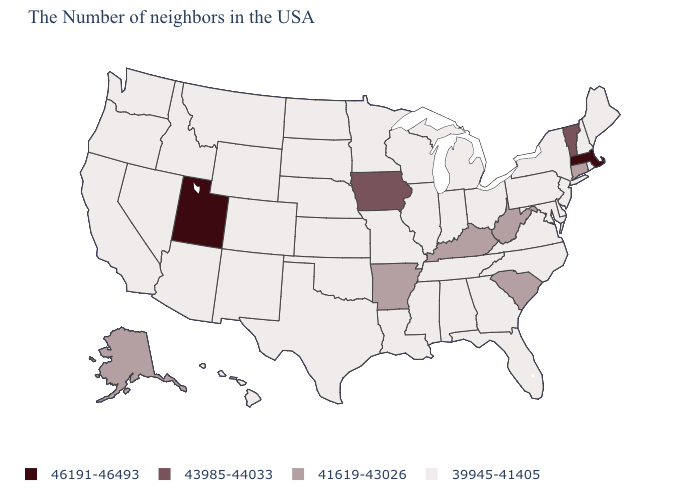Which states have the lowest value in the MidWest?
Answer briefly. Ohio, Michigan, Indiana, Wisconsin, Illinois, Missouri, Minnesota, Kansas, Nebraska, South Dakota, North Dakota. Which states have the lowest value in the South?
Quick response, please. Delaware, Maryland, Virginia, North Carolina, Florida, Georgia, Alabama, Tennessee, Mississippi, Louisiana, Oklahoma, Texas. What is the value of Rhode Island?
Give a very brief answer. 39945-41405. How many symbols are there in the legend?
Answer briefly. 4. Name the states that have a value in the range 46191-46493?
Give a very brief answer. Massachusetts, Utah. Does Minnesota have a lower value than Connecticut?
Short answer required. Yes. Name the states that have a value in the range 41619-43026?
Short answer required. Connecticut, South Carolina, West Virginia, Kentucky, Arkansas, Alaska. Name the states that have a value in the range 41619-43026?
Write a very short answer. Connecticut, South Carolina, West Virginia, Kentucky, Arkansas, Alaska. Which states have the highest value in the USA?
Keep it brief. Massachusetts, Utah. Does the map have missing data?
Keep it brief. No. What is the value of Louisiana?
Write a very short answer. 39945-41405. Does the first symbol in the legend represent the smallest category?
Keep it brief. No. What is the highest value in the MidWest ?
Quick response, please. 43985-44033. What is the value of Kentucky?
Answer briefly. 41619-43026. Does North Dakota have the lowest value in the USA?
Give a very brief answer. Yes. 